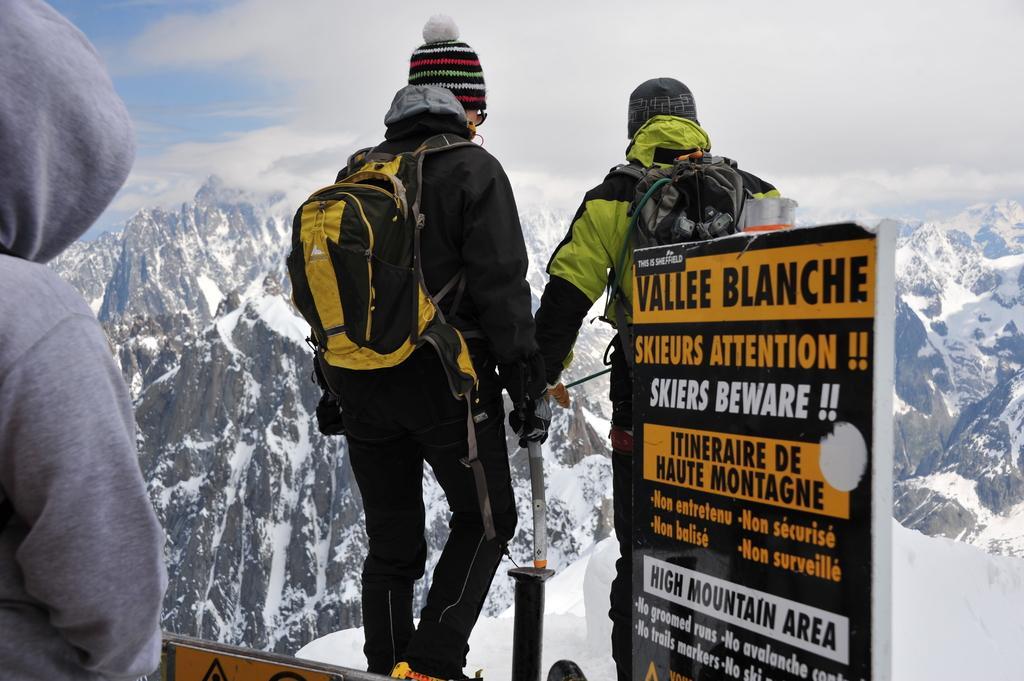In one or two sentences, can you explain what this image depicts? In the center of the image we can see two persons are standing and they are wearing backpacks and hats. And we can see they are in different costumes and the left side person is holding some object. And we can see one pole and banners. On the banners, we can see some text. On the left side of the image, we can see one person wearing a jacket. In the background we can see the sky, clouds, hills, snow and a few other objects. 